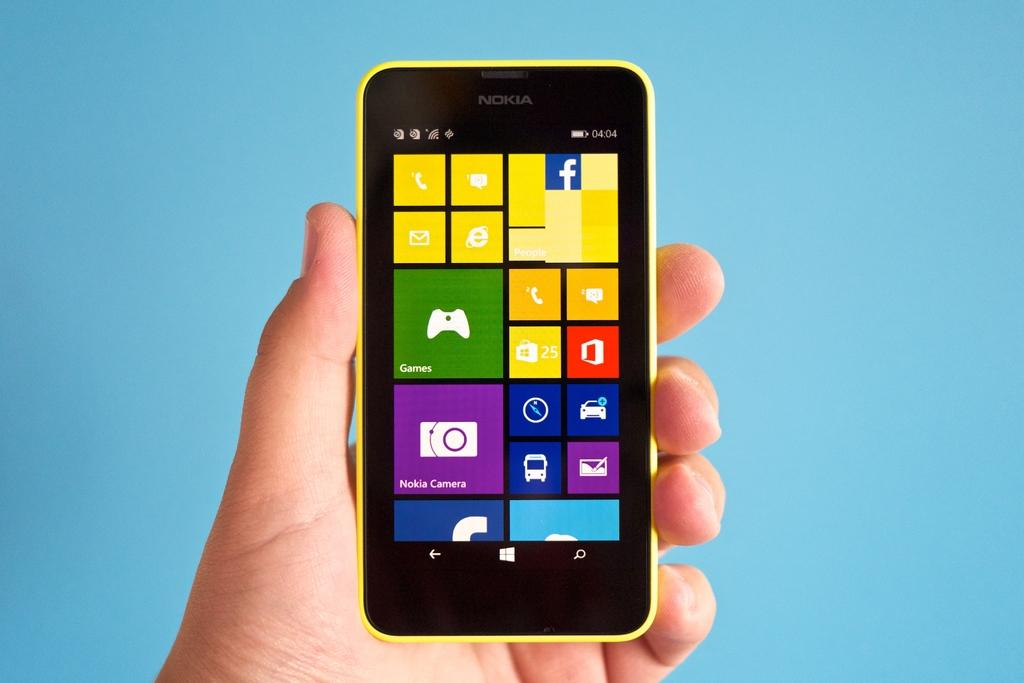<image>
Offer a succinct explanation of the picture presented. a phone that has the word Nokia camera on it 